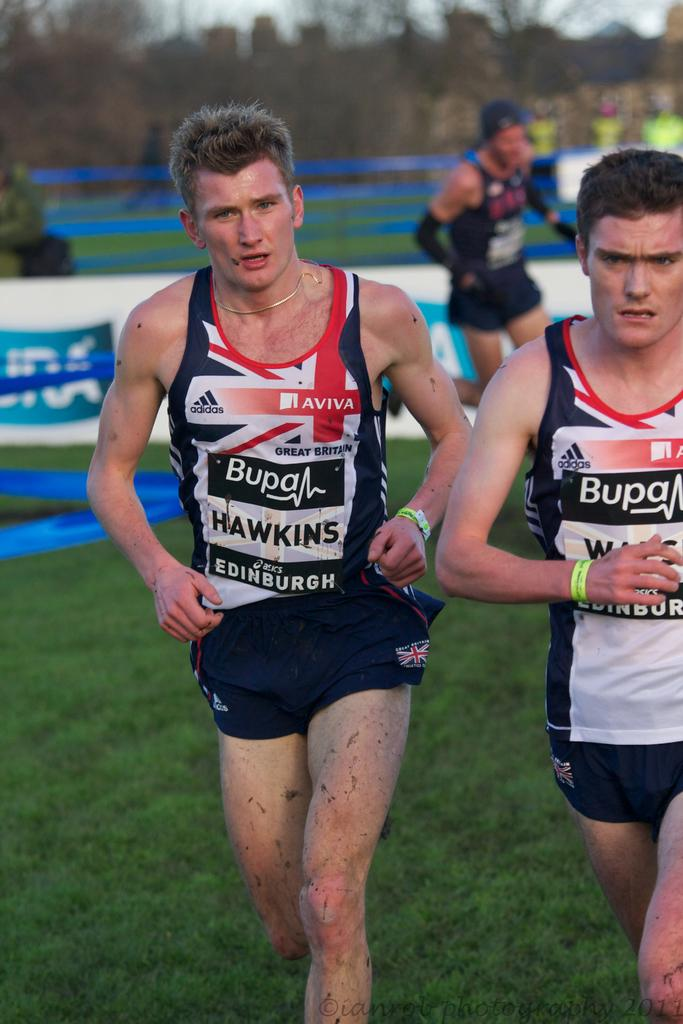<image>
Offer a succinct explanation of the picture presented. a man running with another man that have Hawkins on their shirts 